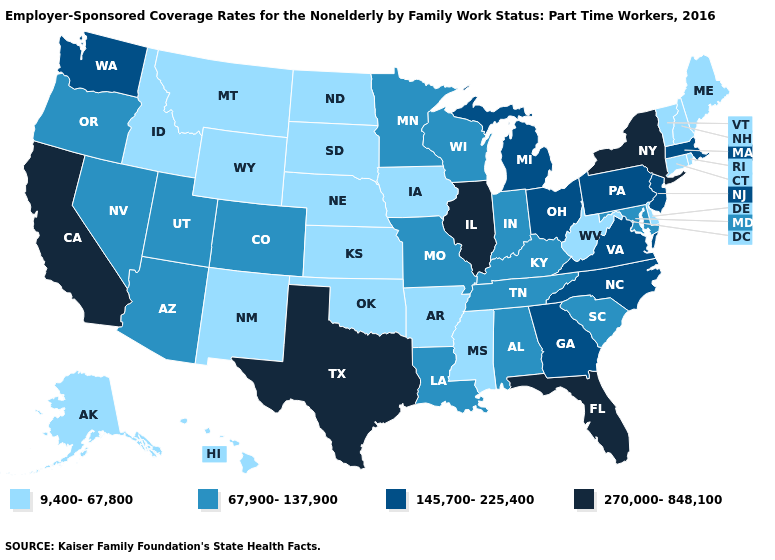What is the value of New Hampshire?
Give a very brief answer. 9,400-67,800. What is the highest value in states that border South Dakota?
Quick response, please. 67,900-137,900. Is the legend a continuous bar?
Short answer required. No. Name the states that have a value in the range 67,900-137,900?
Keep it brief. Alabama, Arizona, Colorado, Indiana, Kentucky, Louisiana, Maryland, Minnesota, Missouri, Nevada, Oregon, South Carolina, Tennessee, Utah, Wisconsin. Which states have the highest value in the USA?
Quick response, please. California, Florida, Illinois, New York, Texas. Is the legend a continuous bar?
Quick response, please. No. Among the states that border Maryland , does Delaware have the highest value?
Short answer required. No. Does Idaho have a lower value than New York?
Quick response, please. Yes. Does Oklahoma have the same value as Kentucky?
Keep it brief. No. Name the states that have a value in the range 9,400-67,800?
Concise answer only. Alaska, Arkansas, Connecticut, Delaware, Hawaii, Idaho, Iowa, Kansas, Maine, Mississippi, Montana, Nebraska, New Hampshire, New Mexico, North Dakota, Oklahoma, Rhode Island, South Dakota, Vermont, West Virginia, Wyoming. Does Texas have the highest value in the USA?
Keep it brief. Yes. What is the lowest value in the USA?
Give a very brief answer. 9,400-67,800. What is the value of South Carolina?
Keep it brief. 67,900-137,900. Does Florida have the highest value in the USA?
Quick response, please. Yes. What is the lowest value in states that border Iowa?
Short answer required. 9,400-67,800. 